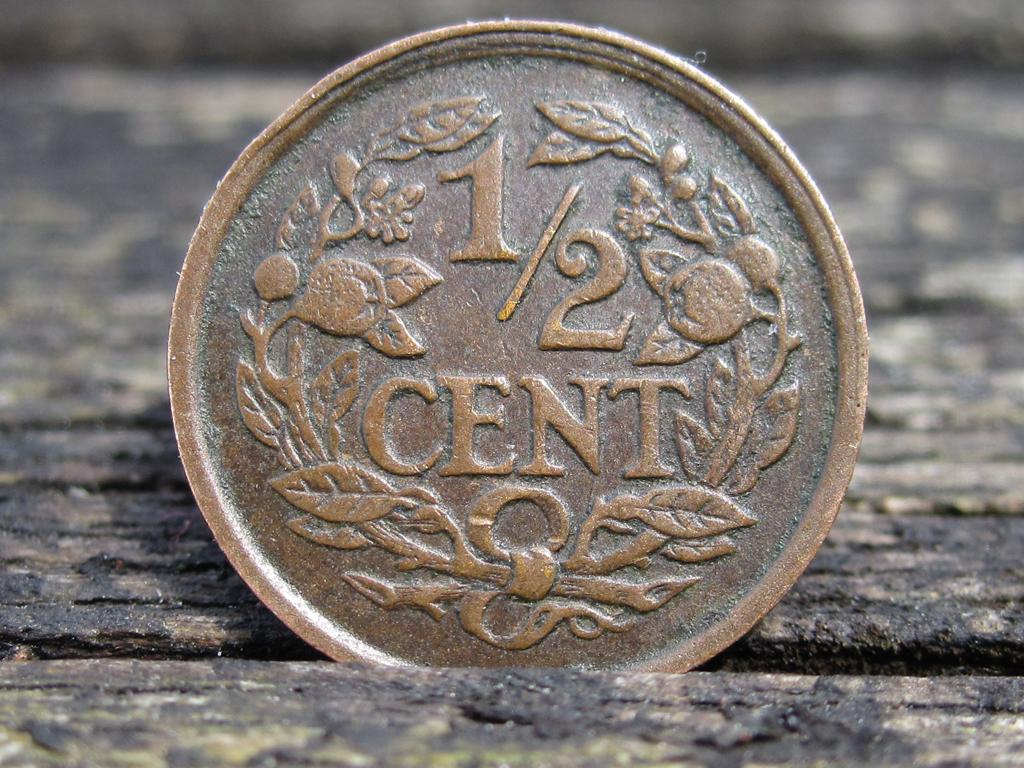<image>
Describe the image concisely. An old coin worth half a cent sits in a crack between wood planks. 